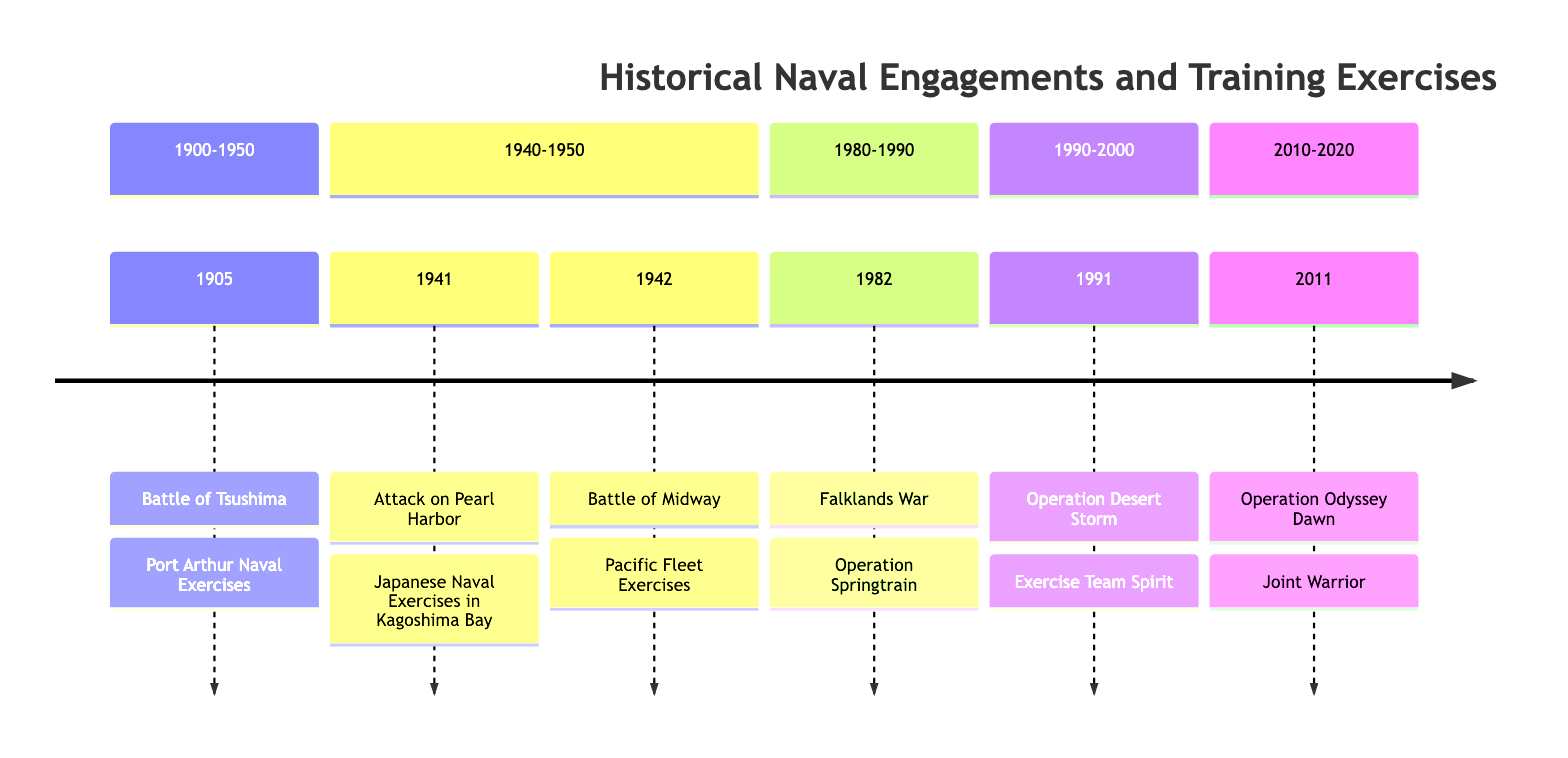What is the naval engagement in 1941? The timeline indicates that the naval engagement in 1941 is the Attack on Pearl Harbor. This information is straightforward, as it directly identifies the event for that year on the diagram.
Answer: Attack on Pearl Harbor How many training exercises are listed in the timeline? By counting the listed training exercises alongside each naval engagement in the timeline, we find a total of six exercises mentioned. This involves reviewing each entry and summing them up.
Answer: 6 What was the training exercise before the Battle of Tsushima? According to the timeline, the training exercise that preceded the Battle of Tsushima in 1905 is the Port Arthur Naval Exercises. The diagram explicitly links the naval engagement to its respective training.
Answer: Port Arthur Naval Exercises Which naval engagement follows the Falklands War? The timeline shows that the naval engagement that follows the Falklands War in 1982 is Operation Desert Storm in 1991. The structure of the timeline lists events chronologically, enabling us to identify the next engagement easily.
Answer: Operation Desert Storm What year did the Joint Warrior exercise occur? The timeline clearly identifies that the Joint Warrior exercise took place in 2011, immediately associated with the naval engagement Operation Odyssey Dawn. This is straightforward to determine by locating the year on the diagram.
Answer: 2011 What is the common theme in the years 1941 and 1942? The common theme is that both years feature significant naval engagements during World War II, specifically the Attack on Pearl Harbor and the Battle of Midway, respectively. Both events are noted as critical during the same conflict, encapsulating the context of naval warfare during that period.
Answer: World War II Which naval engagement in the timeline is associated with a multi-national training exercise? The naval engagement associated with a multi-national training exercise is the Falklands War in 1982, which is connected to Operation Springtrain. This implies a collaboration among naval forces, clearly outlined in the timeline.
Answer: Falklands War What type of exercises does the U.S. Navy emphasize during Exercise Team Spirit? According to the timeline, Exercise Team Spirit focused on amphibious assault and maritime interdiction tactics. This is a specific detail regarding the nature of the training exercise linked to Operation Desert Storm in 1991.
Answer: Amphibious assault and maritime interdiction tactics 